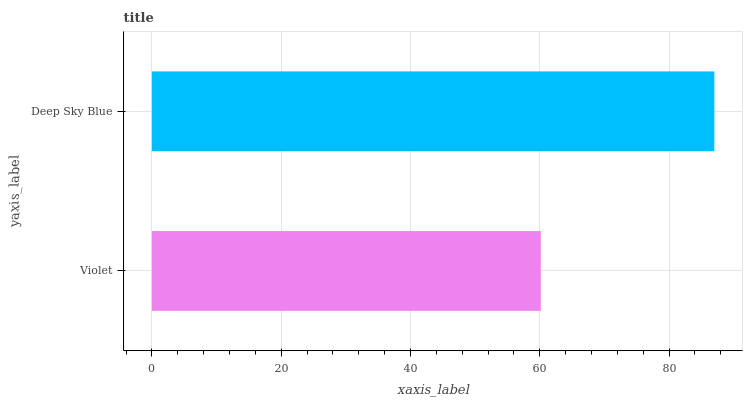Is Violet the minimum?
Answer yes or no. Yes. Is Deep Sky Blue the maximum?
Answer yes or no. Yes. Is Deep Sky Blue the minimum?
Answer yes or no. No. Is Deep Sky Blue greater than Violet?
Answer yes or no. Yes. Is Violet less than Deep Sky Blue?
Answer yes or no. Yes. Is Violet greater than Deep Sky Blue?
Answer yes or no. No. Is Deep Sky Blue less than Violet?
Answer yes or no. No. Is Deep Sky Blue the high median?
Answer yes or no. Yes. Is Violet the low median?
Answer yes or no. Yes. Is Violet the high median?
Answer yes or no. No. Is Deep Sky Blue the low median?
Answer yes or no. No. 